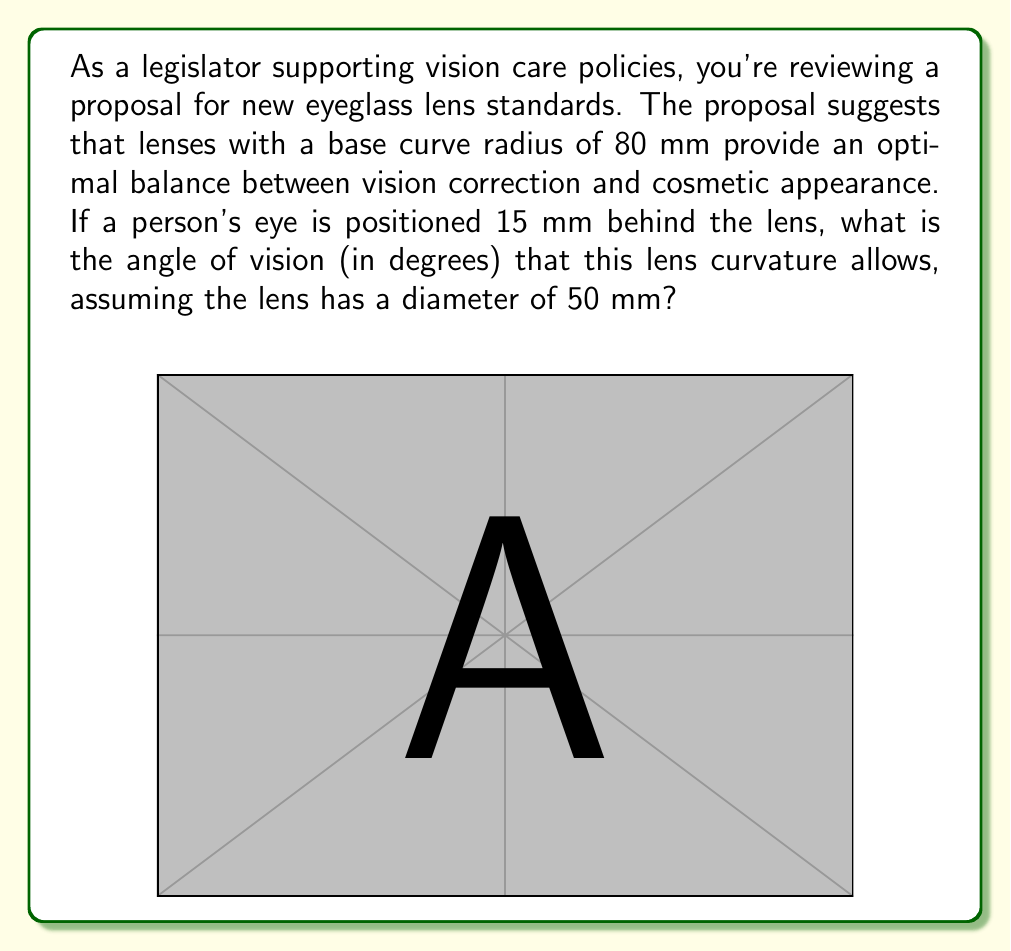Could you help me with this problem? To solve this problem, we need to follow these steps:

1) First, we need to find the angle at the center of the lens curvature. We can do this using the arc length formula:

   $$\theta = \frac{s}{r}$$

   Where $\theta$ is the angle in radians, $s$ is the arc length (which is the lens diameter in this case), and $r$ is the radius of curvature.

2) We have:
   $s = 50$ mm (lens diameter)
   $r = 80$ mm (base curve radius)

3) Plugging these into the formula:

   $$\theta = \frac{50}{80} = 0.625 \text{ radians}$$

4) Now, we need to consider the eye's position. The eye is 15 mm behind the lens, so the effective radius is 80 + 15 = 95 mm.

5) We can now use the formula for the central angle of a circular segment:

   $$\alpha = 2 \arcsin(\frac{a}{2R})$$

   Where $\alpha$ is the angle of vision we're looking for, $a$ is the chord length (lens diameter), and $R$ is the effective radius.

6) Plugging in our values:

   $$\alpha = 2 \arcsin(\frac{50}{2 \cdot 95})$$
   $$\alpha = 2 \arcsin(0.2632)$$
   $$\alpha = 2 \cdot 0.2659$$
   $$\alpha = 0.5318 \text{ radians}$$

7) Converting to degrees:

   $$\alpha = 0.5318 \cdot \frac{180}{\pi} = 30.48°$$

Thus, the angle of vision provided by this lens curvature is approximately 30.48°.
Answer: The angle of vision is approximately 30.48°. 